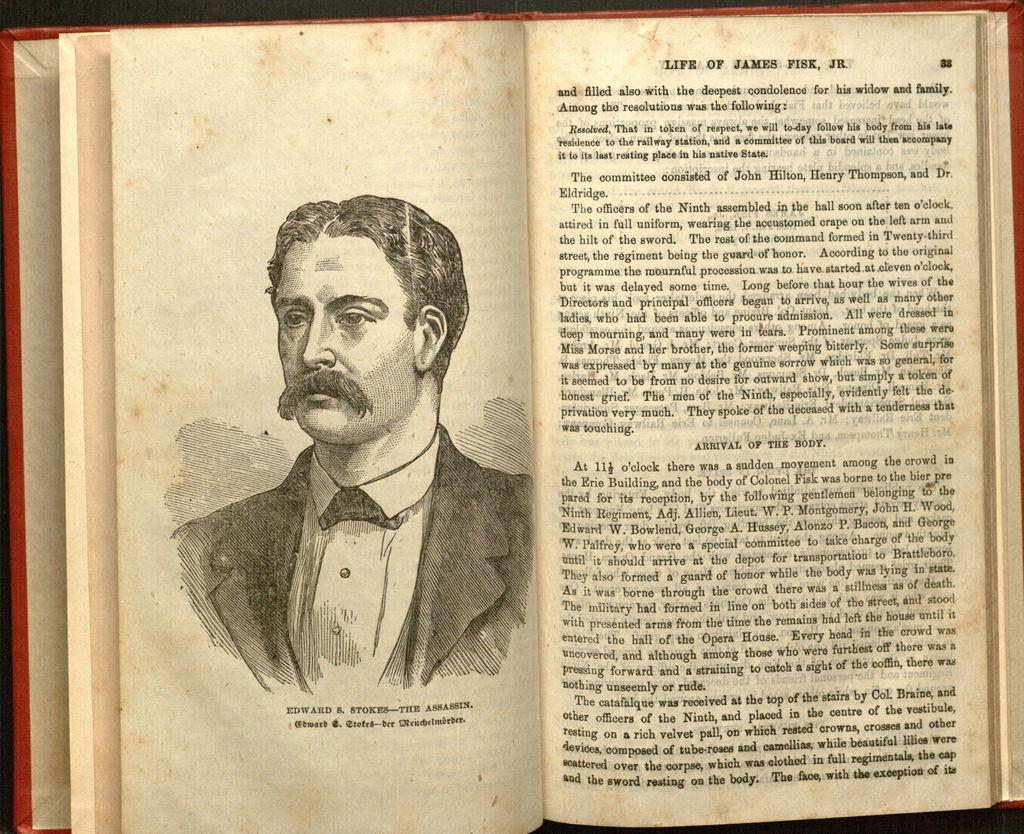What is the main object in the image? There is a book in the image. What can be seen in the book? The book contains an image of a man. What else is present in the book besides the image? There is text in the book. What type of stew is being prepared in the image? There is no stew present in the image; it features a book with an image of a man and text. How many babies are visible in the image? There are no babies present in the image; it features a book with an image of a man and text. 